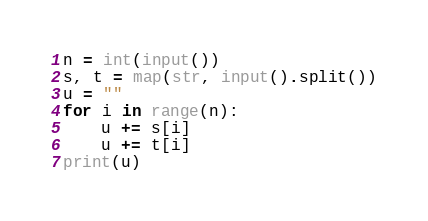<code> <loc_0><loc_0><loc_500><loc_500><_Python_>n = int(input())
s, t = map(str, input().split())
u = ""
for i in range(n):
    u += s[i]
    u += t[i]
print(u)
</code> 